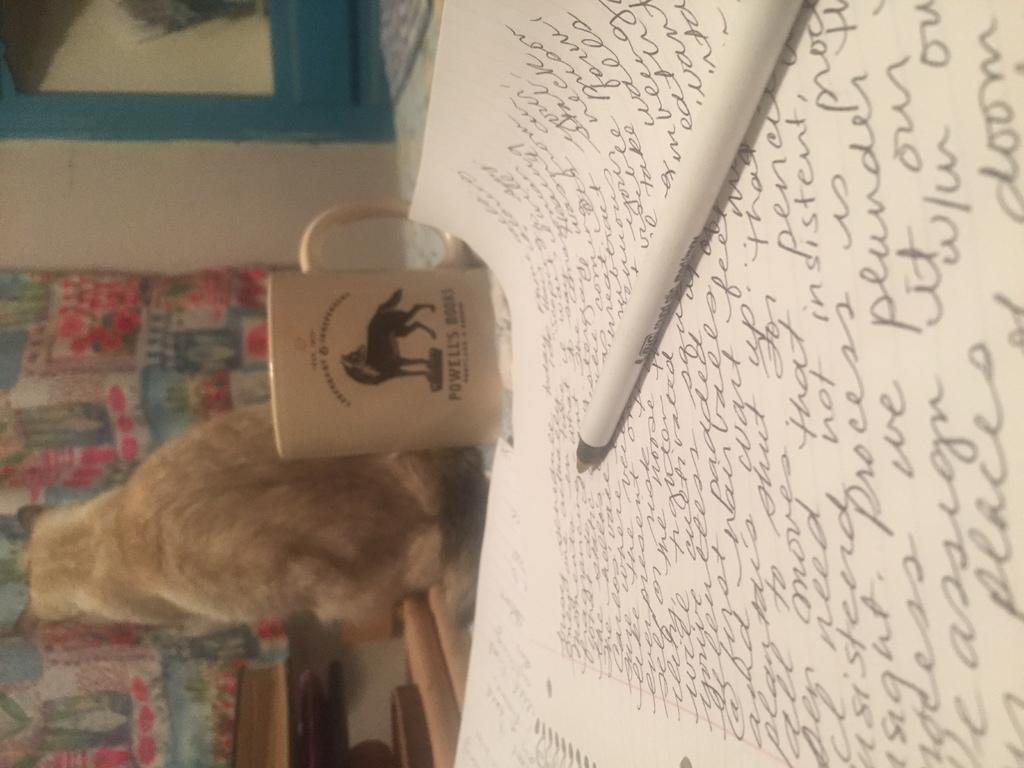What object is placed on the paper in the image? There is a pen on the paper in the image. What is located beside the paper? The paper is beside a cup in the image. What animal is visible in the image? There is a cat beside the paper and cup in the image. What can be seen in the background of the image? There are curtains in the background of the image. How many frogs are sitting on the pen in the image? There are no frogs present in the image; only a pen, paper, cup, and cat are visible. 